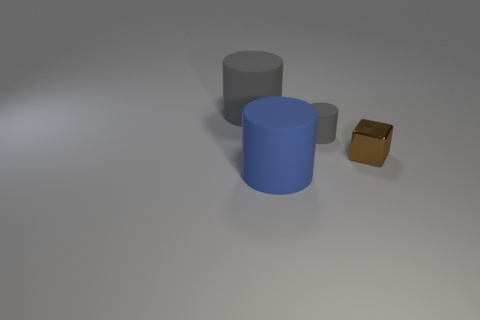Is the color of the small metallic object the same as the tiny matte thing?
Your response must be concise. No. What number of rubber objects are both behind the small gray cylinder and to the right of the large gray thing?
Offer a terse response. 0. What number of gray things are left of the cylinder to the right of the large rubber thing that is on the right side of the big gray cylinder?
Offer a very short reply. 1. The cylinder that is the same color as the tiny rubber object is what size?
Offer a terse response. Large. The metal object has what shape?
Make the answer very short. Cube. How many large gray cylinders have the same material as the tiny cylinder?
Keep it short and to the point. 1. What is the color of the other small cylinder that is the same material as the blue cylinder?
Ensure brevity in your answer.  Gray. Do the brown thing and the gray cylinder in front of the large gray thing have the same size?
Keep it short and to the point. Yes. There is a big thing behind the large matte cylinder that is in front of the gray cylinder on the left side of the small matte thing; what is it made of?
Offer a terse response. Rubber. What number of objects are large red cylinders or small brown metal things?
Your answer should be very brief. 1. 